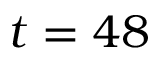Convert formula to latex. <formula><loc_0><loc_0><loc_500><loc_500>t = 4 8</formula> 